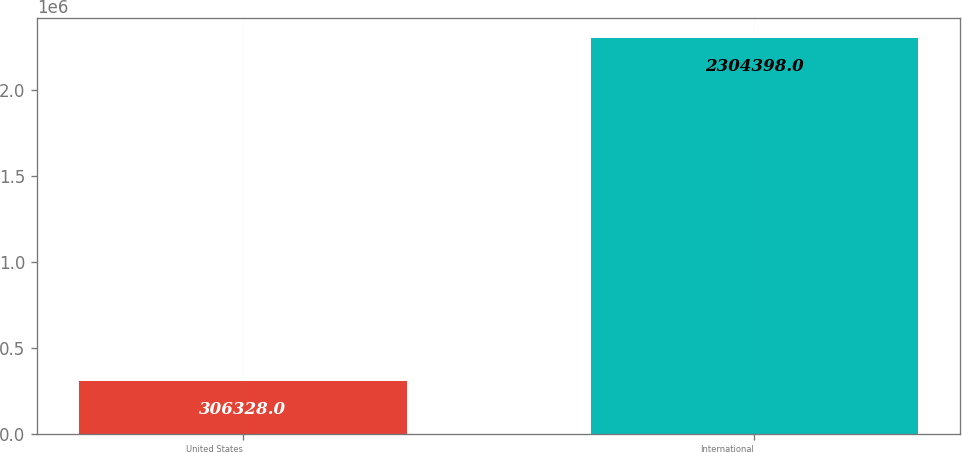Convert chart. <chart><loc_0><loc_0><loc_500><loc_500><bar_chart><fcel>United States<fcel>International<nl><fcel>306328<fcel>2.3044e+06<nl></chart> 